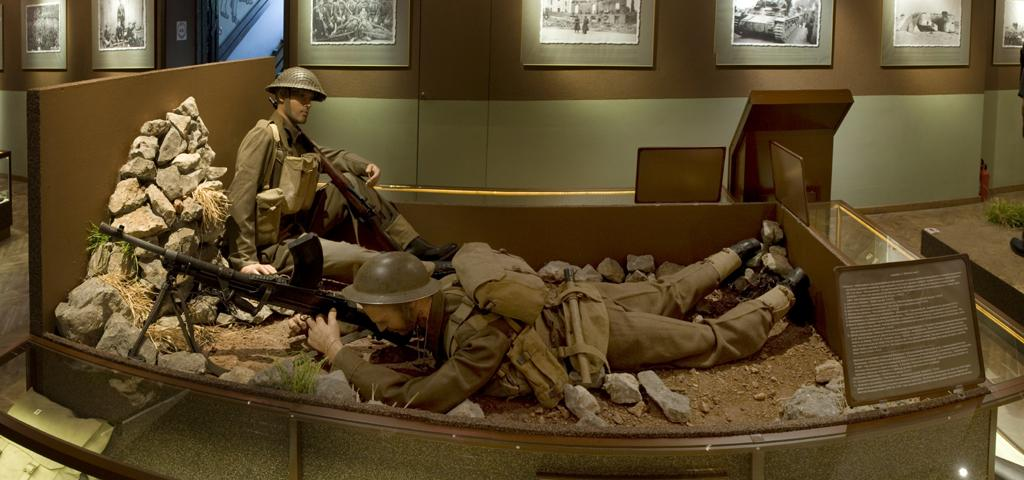What subjects are depicted in the image as statues? There are two statues of soldiers in the image. What can be seen in the foreground of the image? There are stones in the foreground area of the image. What is present at the top side of the image? There are frames at the top side of the image. What is the relation between the zebra and the soldier statues in the image? There is no zebra present in the image, so there is no relation between a zebra and the soldier statues. 